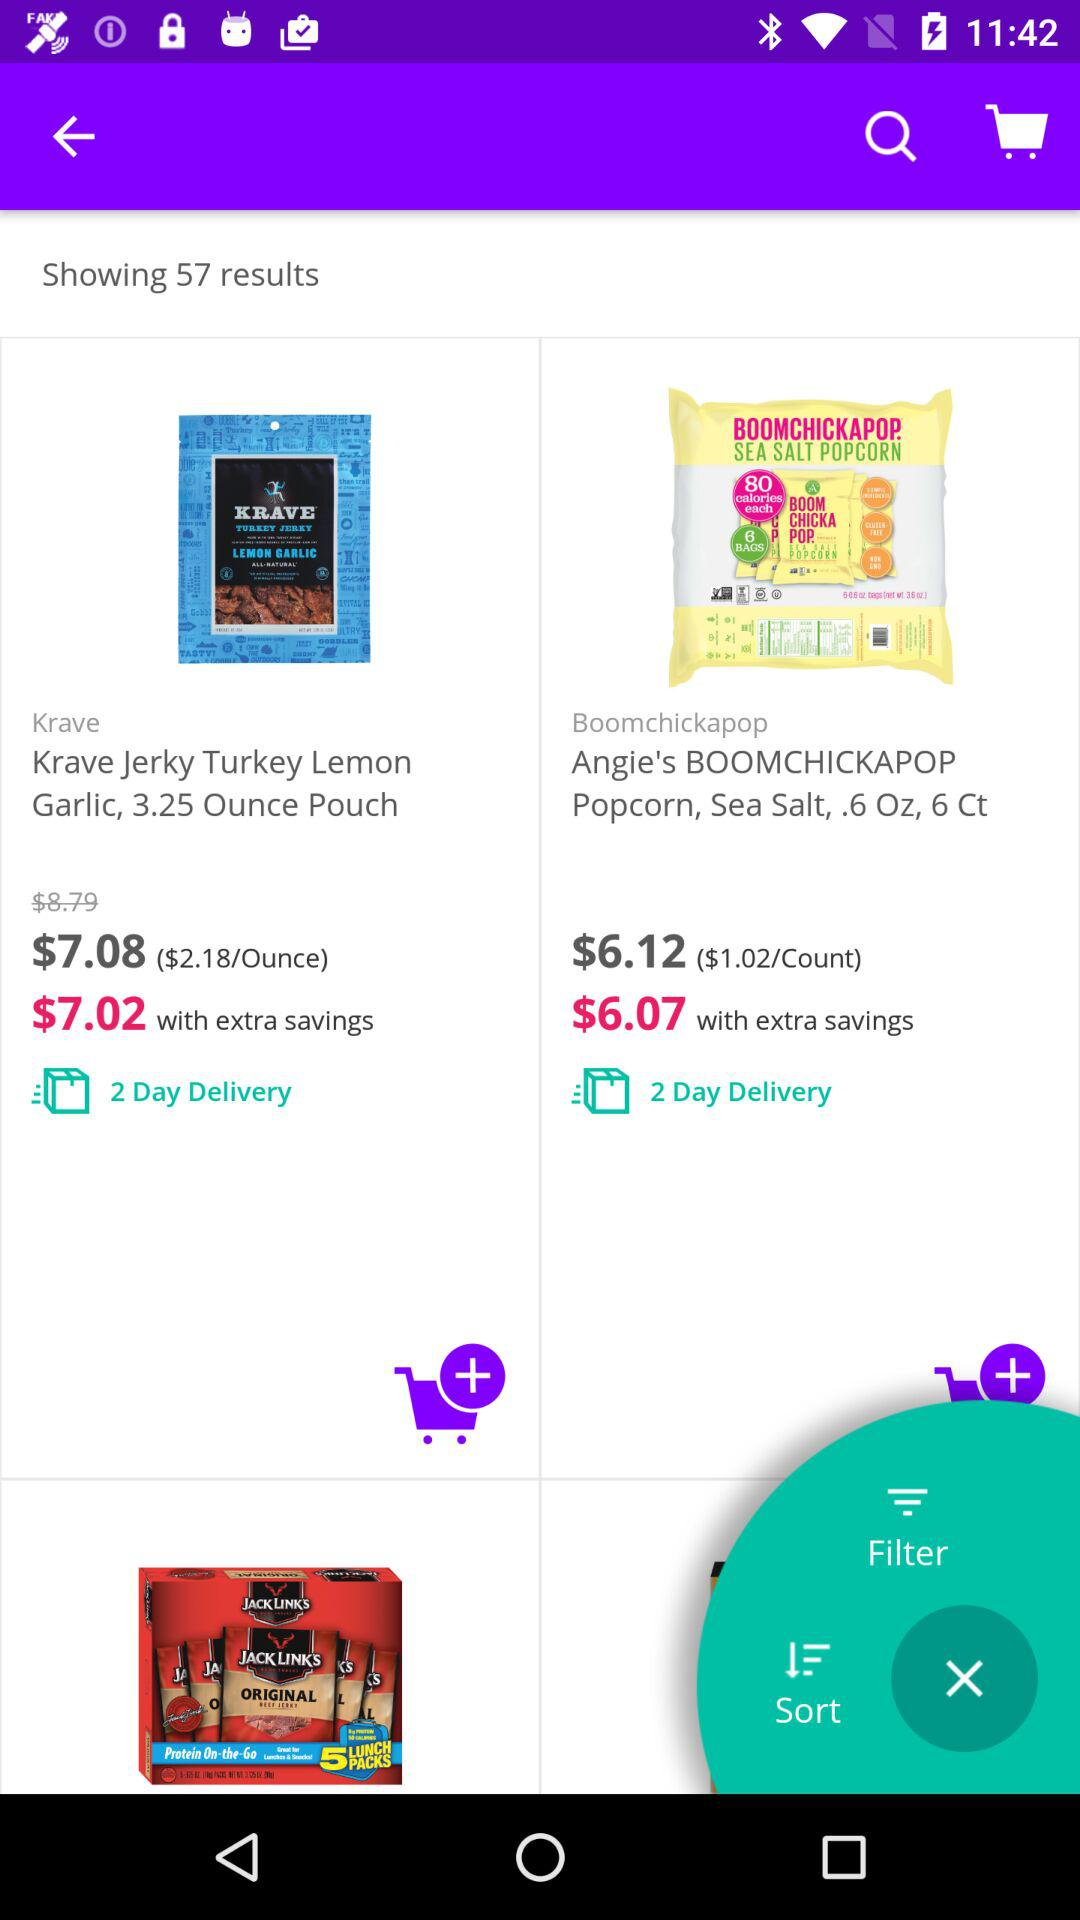What is the delivery period for "Angie's BOOMCHICKAPOP Popcorn"? The delivery period for "Angie's BOOMCHICKAPOP Popcorn" is 2 days. 